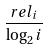<formula> <loc_0><loc_0><loc_500><loc_500>\frac { r e l _ { i } } { \log _ { 2 } i }</formula> 